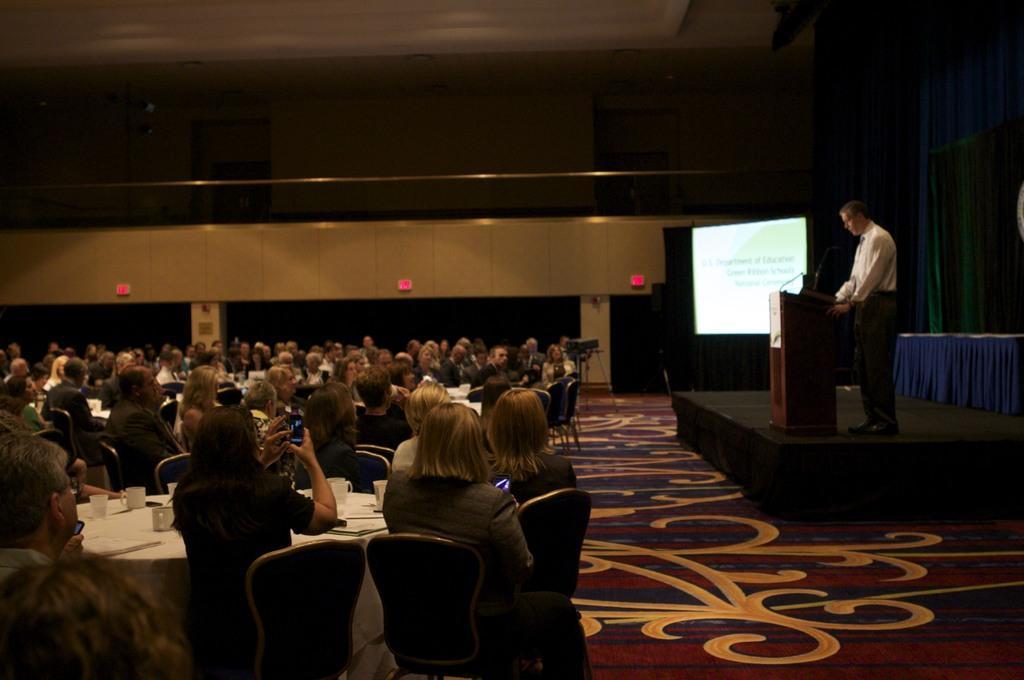Describe this image in one or two sentences. In this picture I can see a group of the people are sitting on chairs in front of tables. On the tables I can see some objects. On the right side I can see a man is standing in front of a podium which has a microphone on it. Here I can see a wall and a projector screen in the background. 